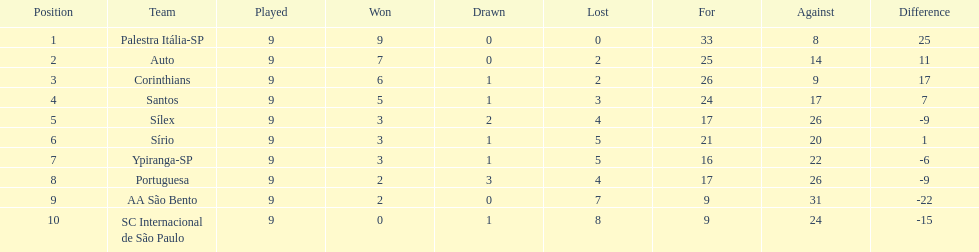How many teams had more points than silex? 4. 